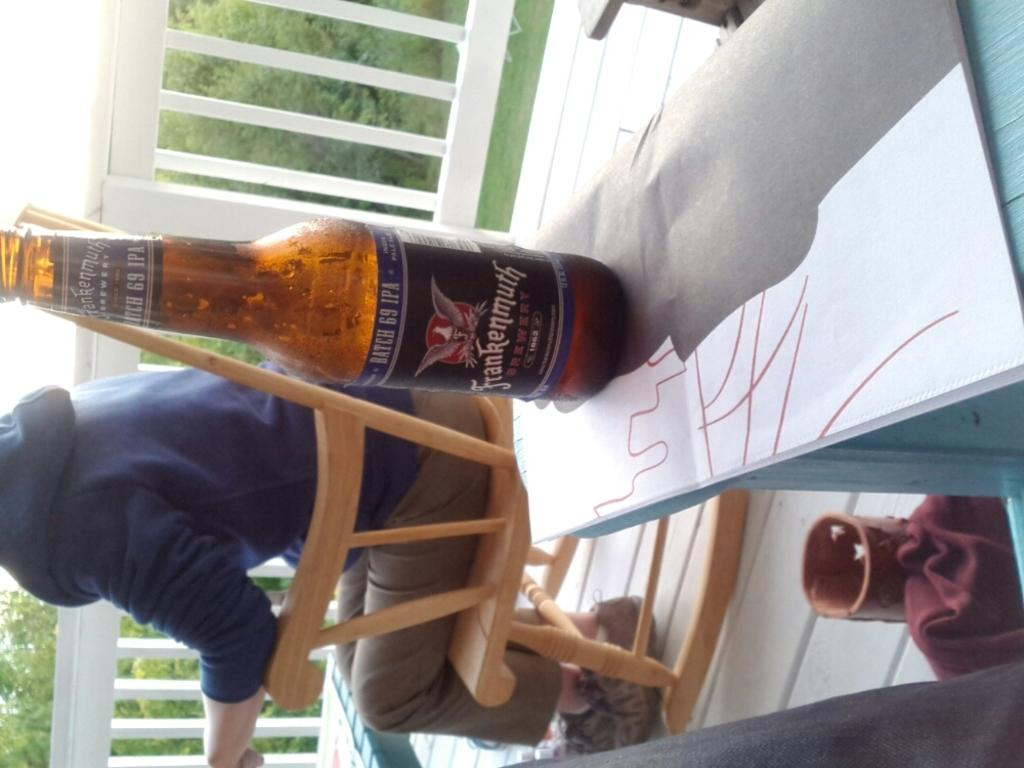Provide a one-sentence caption for the provided image. A beer bottle label indicates that the product has a Batch 69 IPA. 